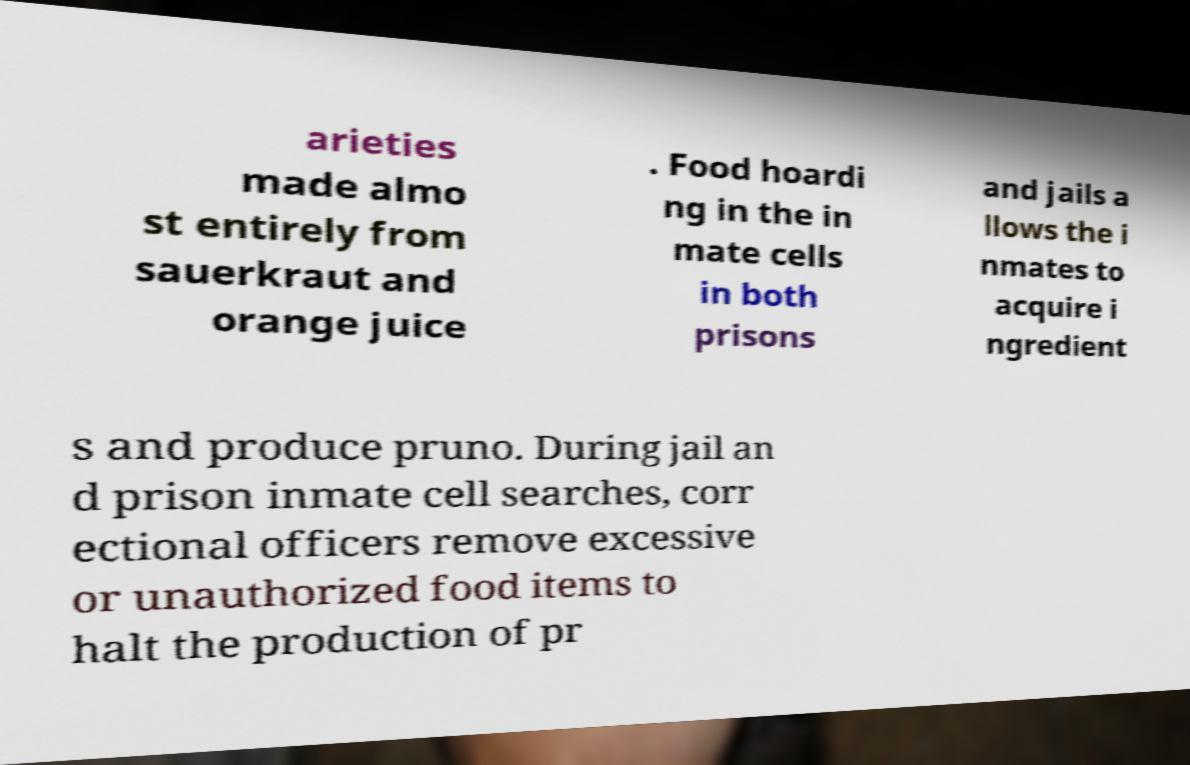Could you assist in decoding the text presented in this image and type it out clearly? arieties made almo st entirely from sauerkraut and orange juice . Food hoardi ng in the in mate cells in both prisons and jails a llows the i nmates to acquire i ngredient s and produce pruno. During jail an d prison inmate cell searches, corr ectional officers remove excessive or unauthorized food items to halt the production of pr 